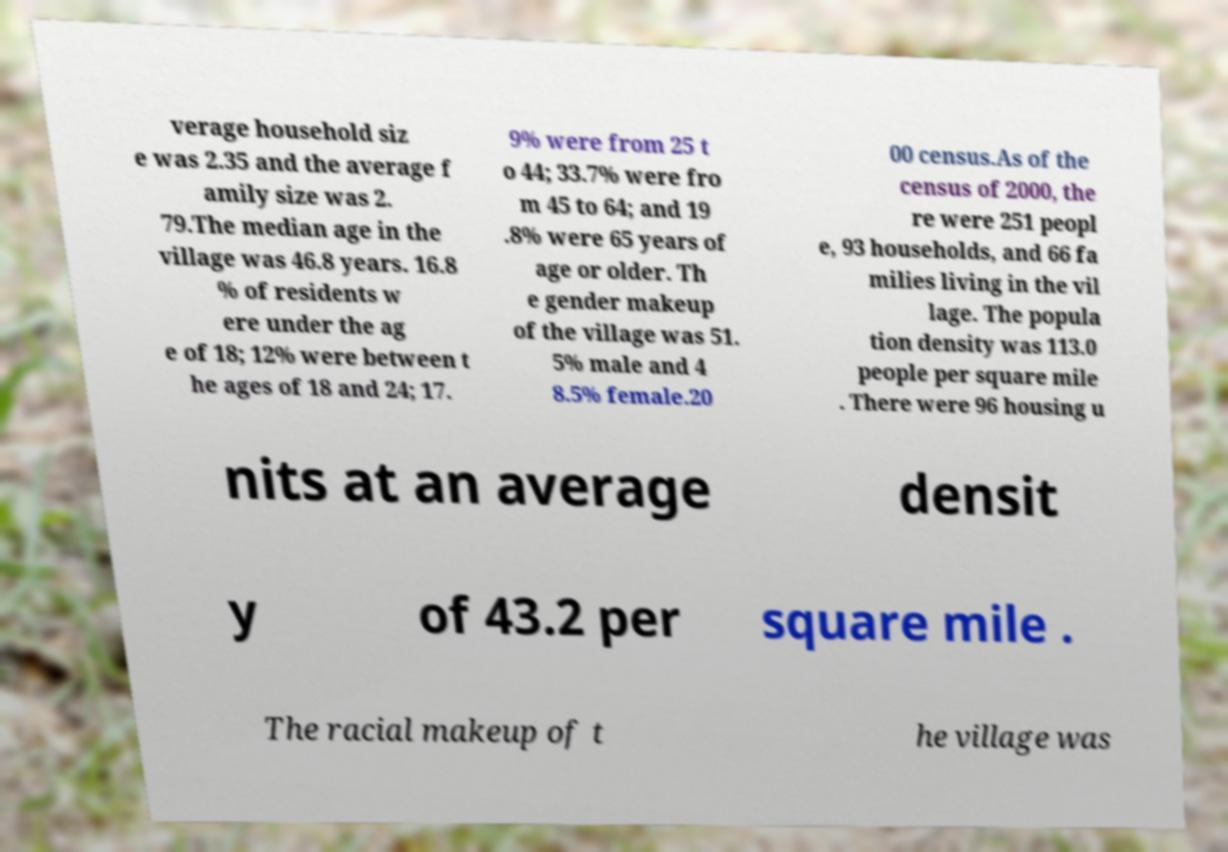I need the written content from this picture converted into text. Can you do that? verage household siz e was 2.35 and the average f amily size was 2. 79.The median age in the village was 46.8 years. 16.8 % of residents w ere under the ag e of 18; 12% were between t he ages of 18 and 24; 17. 9% were from 25 t o 44; 33.7% were fro m 45 to 64; and 19 .8% were 65 years of age or older. Th e gender makeup of the village was 51. 5% male and 4 8.5% female.20 00 census.As of the census of 2000, the re were 251 peopl e, 93 households, and 66 fa milies living in the vil lage. The popula tion density was 113.0 people per square mile . There were 96 housing u nits at an average densit y of 43.2 per square mile . The racial makeup of t he village was 